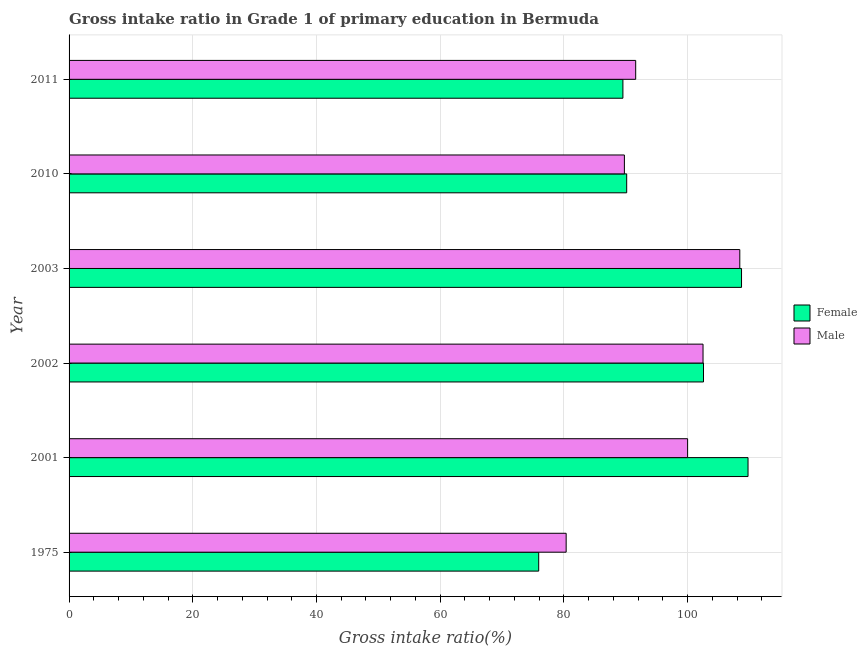How many groups of bars are there?
Your answer should be very brief. 6. Are the number of bars on each tick of the Y-axis equal?
Offer a terse response. Yes. How many bars are there on the 6th tick from the top?
Give a very brief answer. 2. In how many cases, is the number of bars for a given year not equal to the number of legend labels?
Your response must be concise. 0. What is the gross intake ratio(female) in 2002?
Give a very brief answer. 102.57. Across all years, what is the maximum gross intake ratio(female)?
Offer a very short reply. 109.77. Across all years, what is the minimum gross intake ratio(male)?
Offer a terse response. 80.37. In which year was the gross intake ratio(male) maximum?
Offer a very short reply. 2003. In which year was the gross intake ratio(male) minimum?
Your response must be concise. 1975. What is the total gross intake ratio(female) in the graph?
Ensure brevity in your answer.  576.68. What is the difference between the gross intake ratio(male) in 1975 and that in 2002?
Your answer should be very brief. -22.13. What is the difference between the gross intake ratio(female) in 2002 and the gross intake ratio(male) in 2003?
Give a very brief answer. -5.87. What is the average gross intake ratio(female) per year?
Your answer should be compact. 96.11. In the year 1975, what is the difference between the gross intake ratio(female) and gross intake ratio(male)?
Offer a very short reply. -4.44. In how many years, is the gross intake ratio(male) greater than 24 %?
Your response must be concise. 6. What is the ratio of the gross intake ratio(male) in 2003 to that in 2010?
Provide a short and direct response. 1.21. Is the gross intake ratio(male) in 1975 less than that in 2011?
Ensure brevity in your answer.  Yes. What is the difference between the highest and the second highest gross intake ratio(female)?
Offer a terse response. 1.05. What is the difference between the highest and the lowest gross intake ratio(female)?
Offer a very short reply. 33.84. In how many years, is the gross intake ratio(female) greater than the average gross intake ratio(female) taken over all years?
Provide a succinct answer. 3. What does the 2nd bar from the top in 2011 represents?
Your response must be concise. Female. Are all the bars in the graph horizontal?
Offer a very short reply. Yes. How many years are there in the graph?
Give a very brief answer. 6. What is the difference between two consecutive major ticks on the X-axis?
Your answer should be very brief. 20. Are the values on the major ticks of X-axis written in scientific E-notation?
Give a very brief answer. No. Does the graph contain grids?
Ensure brevity in your answer.  Yes. Where does the legend appear in the graph?
Offer a very short reply. Center right. How are the legend labels stacked?
Offer a very short reply. Vertical. What is the title of the graph?
Ensure brevity in your answer.  Gross intake ratio in Grade 1 of primary education in Bermuda. What is the label or title of the X-axis?
Give a very brief answer. Gross intake ratio(%). What is the Gross intake ratio(%) of Female in 1975?
Make the answer very short. 75.93. What is the Gross intake ratio(%) of Male in 1975?
Ensure brevity in your answer.  80.37. What is the Gross intake ratio(%) of Female in 2001?
Offer a very short reply. 109.77. What is the Gross intake ratio(%) in Female in 2002?
Provide a short and direct response. 102.57. What is the Gross intake ratio(%) in Male in 2002?
Ensure brevity in your answer.  102.49. What is the Gross intake ratio(%) in Female in 2003?
Keep it short and to the point. 108.72. What is the Gross intake ratio(%) of Male in 2003?
Keep it short and to the point. 108.44. What is the Gross intake ratio(%) of Female in 2010?
Give a very brief answer. 90.15. What is the Gross intake ratio(%) of Male in 2010?
Make the answer very short. 89.78. What is the Gross intake ratio(%) in Female in 2011?
Offer a terse response. 89.54. What is the Gross intake ratio(%) of Male in 2011?
Your response must be concise. 91.6. Across all years, what is the maximum Gross intake ratio(%) of Female?
Provide a short and direct response. 109.77. Across all years, what is the maximum Gross intake ratio(%) of Male?
Provide a short and direct response. 108.44. Across all years, what is the minimum Gross intake ratio(%) in Female?
Keep it short and to the point. 75.93. Across all years, what is the minimum Gross intake ratio(%) of Male?
Provide a succinct answer. 80.37. What is the total Gross intake ratio(%) of Female in the graph?
Provide a succinct answer. 576.68. What is the total Gross intake ratio(%) in Male in the graph?
Offer a very short reply. 572.68. What is the difference between the Gross intake ratio(%) of Female in 1975 and that in 2001?
Keep it short and to the point. -33.84. What is the difference between the Gross intake ratio(%) of Male in 1975 and that in 2001?
Offer a terse response. -19.63. What is the difference between the Gross intake ratio(%) in Female in 1975 and that in 2002?
Offer a very short reply. -26.64. What is the difference between the Gross intake ratio(%) of Male in 1975 and that in 2002?
Ensure brevity in your answer.  -22.13. What is the difference between the Gross intake ratio(%) in Female in 1975 and that in 2003?
Keep it short and to the point. -32.79. What is the difference between the Gross intake ratio(%) in Male in 1975 and that in 2003?
Keep it short and to the point. -28.07. What is the difference between the Gross intake ratio(%) of Female in 1975 and that in 2010?
Ensure brevity in your answer.  -14.23. What is the difference between the Gross intake ratio(%) of Male in 1975 and that in 2010?
Keep it short and to the point. -9.42. What is the difference between the Gross intake ratio(%) of Female in 1975 and that in 2011?
Ensure brevity in your answer.  -13.61. What is the difference between the Gross intake ratio(%) of Male in 1975 and that in 2011?
Make the answer very short. -11.24. What is the difference between the Gross intake ratio(%) in Female in 2001 and that in 2002?
Offer a very short reply. 7.2. What is the difference between the Gross intake ratio(%) in Male in 2001 and that in 2002?
Ensure brevity in your answer.  -2.49. What is the difference between the Gross intake ratio(%) of Female in 2001 and that in 2003?
Keep it short and to the point. 1.05. What is the difference between the Gross intake ratio(%) in Male in 2001 and that in 2003?
Provide a succinct answer. -8.44. What is the difference between the Gross intake ratio(%) in Female in 2001 and that in 2010?
Offer a terse response. 19.62. What is the difference between the Gross intake ratio(%) in Male in 2001 and that in 2010?
Give a very brief answer. 10.22. What is the difference between the Gross intake ratio(%) of Female in 2001 and that in 2011?
Your answer should be very brief. 20.23. What is the difference between the Gross intake ratio(%) of Male in 2001 and that in 2011?
Offer a very short reply. 8.4. What is the difference between the Gross intake ratio(%) in Female in 2002 and that in 2003?
Offer a very short reply. -6.15. What is the difference between the Gross intake ratio(%) of Male in 2002 and that in 2003?
Offer a very short reply. -5.94. What is the difference between the Gross intake ratio(%) in Female in 2002 and that in 2010?
Ensure brevity in your answer.  12.42. What is the difference between the Gross intake ratio(%) of Male in 2002 and that in 2010?
Your answer should be very brief. 12.71. What is the difference between the Gross intake ratio(%) of Female in 2002 and that in 2011?
Provide a succinct answer. 13.03. What is the difference between the Gross intake ratio(%) of Male in 2002 and that in 2011?
Make the answer very short. 10.89. What is the difference between the Gross intake ratio(%) in Female in 2003 and that in 2010?
Give a very brief answer. 18.57. What is the difference between the Gross intake ratio(%) in Male in 2003 and that in 2010?
Provide a short and direct response. 18.66. What is the difference between the Gross intake ratio(%) in Female in 2003 and that in 2011?
Give a very brief answer. 19.18. What is the difference between the Gross intake ratio(%) of Male in 2003 and that in 2011?
Keep it short and to the point. 16.83. What is the difference between the Gross intake ratio(%) of Female in 2010 and that in 2011?
Offer a very short reply. 0.61. What is the difference between the Gross intake ratio(%) in Male in 2010 and that in 2011?
Your answer should be very brief. -1.82. What is the difference between the Gross intake ratio(%) of Female in 1975 and the Gross intake ratio(%) of Male in 2001?
Ensure brevity in your answer.  -24.07. What is the difference between the Gross intake ratio(%) in Female in 1975 and the Gross intake ratio(%) in Male in 2002?
Provide a succinct answer. -26.57. What is the difference between the Gross intake ratio(%) of Female in 1975 and the Gross intake ratio(%) of Male in 2003?
Provide a succinct answer. -32.51. What is the difference between the Gross intake ratio(%) in Female in 1975 and the Gross intake ratio(%) in Male in 2010?
Your response must be concise. -13.86. What is the difference between the Gross intake ratio(%) in Female in 1975 and the Gross intake ratio(%) in Male in 2011?
Provide a short and direct response. -15.68. What is the difference between the Gross intake ratio(%) of Female in 2001 and the Gross intake ratio(%) of Male in 2002?
Provide a succinct answer. 7.27. What is the difference between the Gross intake ratio(%) of Female in 2001 and the Gross intake ratio(%) of Male in 2003?
Make the answer very short. 1.33. What is the difference between the Gross intake ratio(%) in Female in 2001 and the Gross intake ratio(%) in Male in 2010?
Offer a terse response. 19.99. What is the difference between the Gross intake ratio(%) of Female in 2001 and the Gross intake ratio(%) of Male in 2011?
Give a very brief answer. 18.16. What is the difference between the Gross intake ratio(%) of Female in 2002 and the Gross intake ratio(%) of Male in 2003?
Offer a very short reply. -5.87. What is the difference between the Gross intake ratio(%) of Female in 2002 and the Gross intake ratio(%) of Male in 2010?
Your answer should be very brief. 12.79. What is the difference between the Gross intake ratio(%) in Female in 2002 and the Gross intake ratio(%) in Male in 2011?
Your response must be concise. 10.97. What is the difference between the Gross intake ratio(%) in Female in 2003 and the Gross intake ratio(%) in Male in 2010?
Provide a succinct answer. 18.94. What is the difference between the Gross intake ratio(%) of Female in 2003 and the Gross intake ratio(%) of Male in 2011?
Offer a very short reply. 17.11. What is the difference between the Gross intake ratio(%) in Female in 2010 and the Gross intake ratio(%) in Male in 2011?
Provide a succinct answer. -1.45. What is the average Gross intake ratio(%) of Female per year?
Ensure brevity in your answer.  96.11. What is the average Gross intake ratio(%) in Male per year?
Your answer should be compact. 95.45. In the year 1975, what is the difference between the Gross intake ratio(%) of Female and Gross intake ratio(%) of Male?
Give a very brief answer. -4.44. In the year 2001, what is the difference between the Gross intake ratio(%) in Female and Gross intake ratio(%) in Male?
Your response must be concise. 9.77. In the year 2002, what is the difference between the Gross intake ratio(%) in Female and Gross intake ratio(%) in Male?
Provide a succinct answer. 0.08. In the year 2003, what is the difference between the Gross intake ratio(%) of Female and Gross intake ratio(%) of Male?
Your answer should be compact. 0.28. In the year 2010, what is the difference between the Gross intake ratio(%) in Female and Gross intake ratio(%) in Male?
Your answer should be very brief. 0.37. In the year 2011, what is the difference between the Gross intake ratio(%) of Female and Gross intake ratio(%) of Male?
Give a very brief answer. -2.06. What is the ratio of the Gross intake ratio(%) of Female in 1975 to that in 2001?
Your response must be concise. 0.69. What is the ratio of the Gross intake ratio(%) in Male in 1975 to that in 2001?
Give a very brief answer. 0.8. What is the ratio of the Gross intake ratio(%) in Female in 1975 to that in 2002?
Make the answer very short. 0.74. What is the ratio of the Gross intake ratio(%) of Male in 1975 to that in 2002?
Make the answer very short. 0.78. What is the ratio of the Gross intake ratio(%) of Female in 1975 to that in 2003?
Keep it short and to the point. 0.7. What is the ratio of the Gross intake ratio(%) in Male in 1975 to that in 2003?
Ensure brevity in your answer.  0.74. What is the ratio of the Gross intake ratio(%) of Female in 1975 to that in 2010?
Offer a terse response. 0.84. What is the ratio of the Gross intake ratio(%) in Male in 1975 to that in 2010?
Offer a very short reply. 0.9. What is the ratio of the Gross intake ratio(%) in Female in 1975 to that in 2011?
Provide a short and direct response. 0.85. What is the ratio of the Gross intake ratio(%) in Male in 1975 to that in 2011?
Ensure brevity in your answer.  0.88. What is the ratio of the Gross intake ratio(%) of Female in 2001 to that in 2002?
Your response must be concise. 1.07. What is the ratio of the Gross intake ratio(%) in Male in 2001 to that in 2002?
Offer a terse response. 0.98. What is the ratio of the Gross intake ratio(%) in Female in 2001 to that in 2003?
Offer a very short reply. 1.01. What is the ratio of the Gross intake ratio(%) in Male in 2001 to that in 2003?
Provide a succinct answer. 0.92. What is the ratio of the Gross intake ratio(%) of Female in 2001 to that in 2010?
Offer a terse response. 1.22. What is the ratio of the Gross intake ratio(%) of Male in 2001 to that in 2010?
Provide a succinct answer. 1.11. What is the ratio of the Gross intake ratio(%) in Female in 2001 to that in 2011?
Make the answer very short. 1.23. What is the ratio of the Gross intake ratio(%) in Male in 2001 to that in 2011?
Your response must be concise. 1.09. What is the ratio of the Gross intake ratio(%) of Female in 2002 to that in 2003?
Keep it short and to the point. 0.94. What is the ratio of the Gross intake ratio(%) of Male in 2002 to that in 2003?
Provide a succinct answer. 0.95. What is the ratio of the Gross intake ratio(%) in Female in 2002 to that in 2010?
Provide a succinct answer. 1.14. What is the ratio of the Gross intake ratio(%) in Male in 2002 to that in 2010?
Give a very brief answer. 1.14. What is the ratio of the Gross intake ratio(%) in Female in 2002 to that in 2011?
Your response must be concise. 1.15. What is the ratio of the Gross intake ratio(%) of Male in 2002 to that in 2011?
Ensure brevity in your answer.  1.12. What is the ratio of the Gross intake ratio(%) of Female in 2003 to that in 2010?
Offer a terse response. 1.21. What is the ratio of the Gross intake ratio(%) of Male in 2003 to that in 2010?
Ensure brevity in your answer.  1.21. What is the ratio of the Gross intake ratio(%) of Female in 2003 to that in 2011?
Provide a short and direct response. 1.21. What is the ratio of the Gross intake ratio(%) in Male in 2003 to that in 2011?
Provide a succinct answer. 1.18. What is the ratio of the Gross intake ratio(%) of Female in 2010 to that in 2011?
Give a very brief answer. 1.01. What is the ratio of the Gross intake ratio(%) in Male in 2010 to that in 2011?
Provide a short and direct response. 0.98. What is the difference between the highest and the second highest Gross intake ratio(%) of Female?
Your answer should be very brief. 1.05. What is the difference between the highest and the second highest Gross intake ratio(%) in Male?
Make the answer very short. 5.94. What is the difference between the highest and the lowest Gross intake ratio(%) in Female?
Give a very brief answer. 33.84. What is the difference between the highest and the lowest Gross intake ratio(%) in Male?
Offer a very short reply. 28.07. 